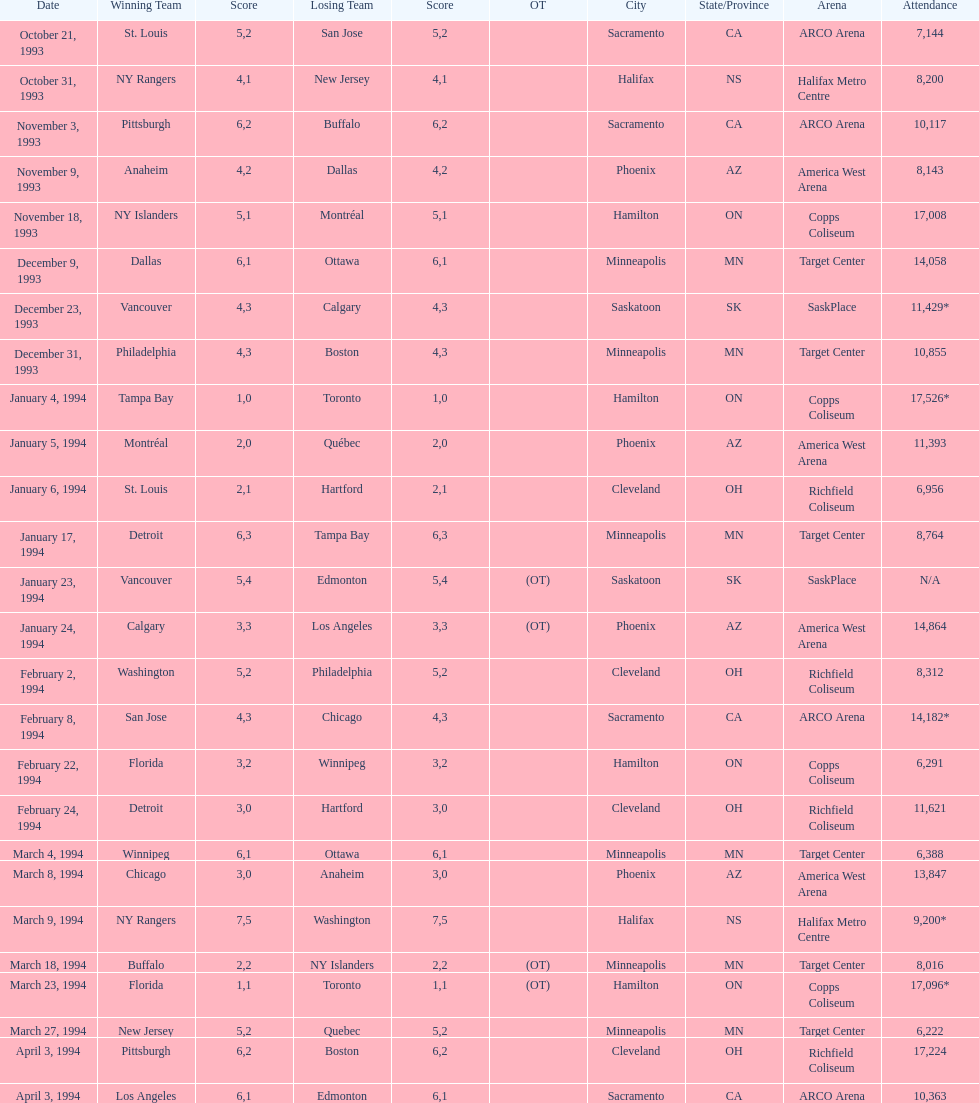Which date had the game with the largest audience? January 4, 1994. 